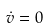Convert formula to latex. <formula><loc_0><loc_0><loc_500><loc_500>\dot { v } = 0</formula> 